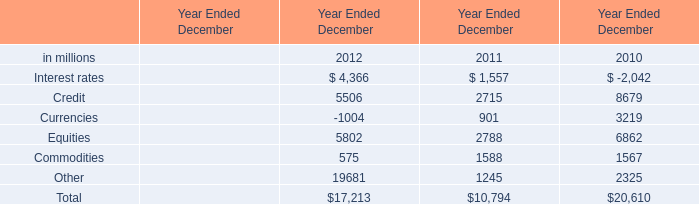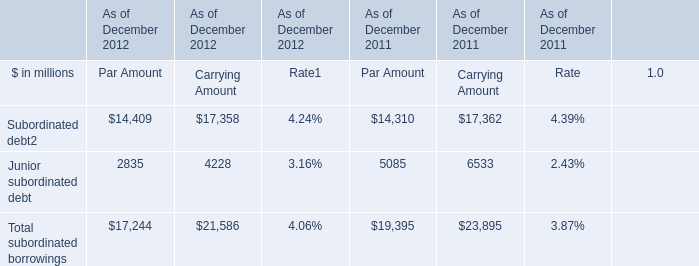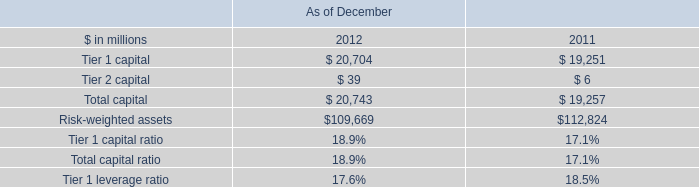What's the average of Credit of Year Ended December 2010, and Subordinated debt of As of December 2011 Carrying Amount ? 
Computations: ((8679.0 + 17362.0) / 2)
Answer: 13020.5. 